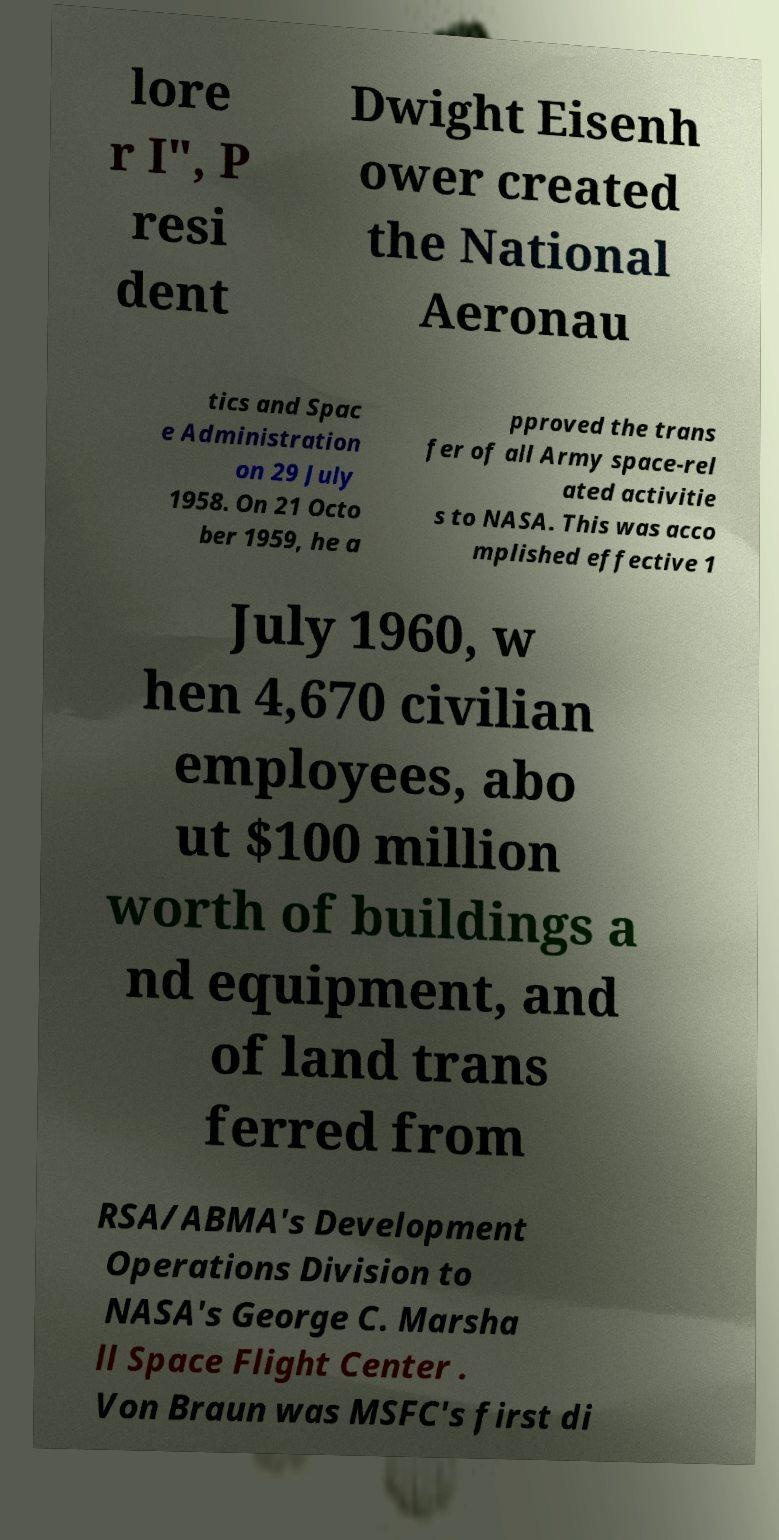Could you extract and type out the text from this image? lore r I", P resi dent Dwight Eisenh ower created the National Aeronau tics and Spac e Administration on 29 July 1958. On 21 Octo ber 1959, he a pproved the trans fer of all Army space-rel ated activitie s to NASA. This was acco mplished effective 1 July 1960, w hen 4,670 civilian employees, abo ut $100 million worth of buildings a nd equipment, and of land trans ferred from RSA/ABMA's Development Operations Division to NASA's George C. Marsha ll Space Flight Center . Von Braun was MSFC's first di 